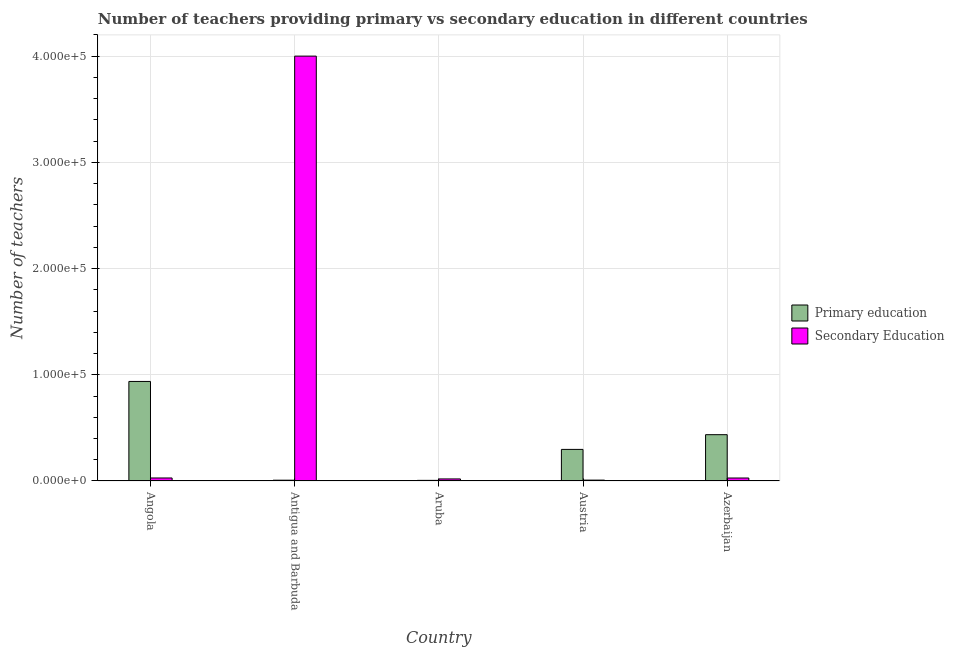How many groups of bars are there?
Offer a very short reply. 5. In how many cases, is the number of bars for a given country not equal to the number of legend labels?
Your answer should be compact. 0. What is the number of primary teachers in Angola?
Keep it short and to the point. 9.37e+04. Across all countries, what is the maximum number of primary teachers?
Provide a succinct answer. 9.37e+04. Across all countries, what is the minimum number of primary teachers?
Provide a short and direct response. 586. In which country was the number of secondary teachers maximum?
Your response must be concise. Antigua and Barbuda. What is the total number of secondary teachers in the graph?
Make the answer very short. 4.08e+05. What is the difference between the number of primary teachers in Angola and that in Aruba?
Offer a terse response. 9.31e+04. What is the difference between the number of primary teachers in Angola and the number of secondary teachers in Aruba?
Offer a very short reply. 9.18e+04. What is the average number of primary teachers per country?
Make the answer very short. 3.37e+04. What is the difference between the number of secondary teachers and number of primary teachers in Azerbaijan?
Your response must be concise. -4.08e+04. In how many countries, is the number of primary teachers greater than 140000 ?
Make the answer very short. 0. What is the ratio of the number of primary teachers in Antigua and Barbuda to that in Austria?
Provide a short and direct response. 0.03. What is the difference between the highest and the second highest number of secondary teachers?
Provide a short and direct response. 3.97e+05. What is the difference between the highest and the lowest number of secondary teachers?
Offer a terse response. 3.99e+05. In how many countries, is the number of primary teachers greater than the average number of primary teachers taken over all countries?
Offer a very short reply. 2. What does the 2nd bar from the left in Aruba represents?
Your response must be concise. Secondary Education. What does the 1st bar from the right in Austria represents?
Ensure brevity in your answer.  Secondary Education. Are all the bars in the graph horizontal?
Your answer should be very brief. No. How many countries are there in the graph?
Your answer should be compact. 5. What is the difference between two consecutive major ticks on the Y-axis?
Offer a very short reply. 1.00e+05. Are the values on the major ticks of Y-axis written in scientific E-notation?
Make the answer very short. Yes. Does the graph contain grids?
Make the answer very short. Yes. How many legend labels are there?
Make the answer very short. 2. What is the title of the graph?
Give a very brief answer. Number of teachers providing primary vs secondary education in different countries. Does "Secondary school" appear as one of the legend labels in the graph?
Provide a short and direct response. No. What is the label or title of the X-axis?
Your response must be concise. Country. What is the label or title of the Y-axis?
Your response must be concise. Number of teachers. What is the Number of teachers of Primary education in Angola?
Offer a very short reply. 9.37e+04. What is the Number of teachers in Secondary Education in Angola?
Keep it short and to the point. 2837. What is the Number of teachers in Primary education in Antigua and Barbuda?
Ensure brevity in your answer.  747. What is the Number of teachers of Secondary Education in Antigua and Barbuda?
Give a very brief answer. 4.00e+05. What is the Number of teachers of Primary education in Aruba?
Provide a short and direct response. 586. What is the Number of teachers of Secondary Education in Aruba?
Offer a very short reply. 1947. What is the Number of teachers in Primary education in Austria?
Your answer should be very brief. 2.97e+04. What is the Number of teachers in Secondary Education in Austria?
Keep it short and to the point. 825. What is the Number of teachers in Primary education in Azerbaijan?
Make the answer very short. 4.36e+04. What is the Number of teachers in Secondary Education in Azerbaijan?
Your response must be concise. 2805. Across all countries, what is the maximum Number of teachers in Primary education?
Your answer should be very brief. 9.37e+04. Across all countries, what is the maximum Number of teachers of Secondary Education?
Provide a short and direct response. 4.00e+05. Across all countries, what is the minimum Number of teachers of Primary education?
Keep it short and to the point. 586. Across all countries, what is the minimum Number of teachers in Secondary Education?
Make the answer very short. 825. What is the total Number of teachers in Primary education in the graph?
Make the answer very short. 1.68e+05. What is the total Number of teachers in Secondary Education in the graph?
Ensure brevity in your answer.  4.08e+05. What is the difference between the Number of teachers of Primary education in Angola and that in Antigua and Barbuda?
Provide a short and direct response. 9.30e+04. What is the difference between the Number of teachers in Secondary Education in Angola and that in Antigua and Barbuda?
Give a very brief answer. -3.97e+05. What is the difference between the Number of teachers in Primary education in Angola and that in Aruba?
Ensure brevity in your answer.  9.31e+04. What is the difference between the Number of teachers of Secondary Education in Angola and that in Aruba?
Offer a very short reply. 890. What is the difference between the Number of teachers in Primary education in Angola and that in Austria?
Provide a short and direct response. 6.40e+04. What is the difference between the Number of teachers in Secondary Education in Angola and that in Austria?
Provide a succinct answer. 2012. What is the difference between the Number of teachers of Primary education in Angola and that in Azerbaijan?
Your answer should be compact. 5.01e+04. What is the difference between the Number of teachers of Secondary Education in Angola and that in Azerbaijan?
Give a very brief answer. 32. What is the difference between the Number of teachers of Primary education in Antigua and Barbuda and that in Aruba?
Your answer should be compact. 161. What is the difference between the Number of teachers of Secondary Education in Antigua and Barbuda and that in Aruba?
Provide a succinct answer. 3.98e+05. What is the difference between the Number of teachers in Primary education in Antigua and Barbuda and that in Austria?
Make the answer very short. -2.90e+04. What is the difference between the Number of teachers in Secondary Education in Antigua and Barbuda and that in Austria?
Your answer should be very brief. 3.99e+05. What is the difference between the Number of teachers in Primary education in Antigua and Barbuda and that in Azerbaijan?
Your answer should be compact. -4.29e+04. What is the difference between the Number of teachers of Secondary Education in Antigua and Barbuda and that in Azerbaijan?
Make the answer very short. 3.97e+05. What is the difference between the Number of teachers in Primary education in Aruba and that in Austria?
Offer a very short reply. -2.92e+04. What is the difference between the Number of teachers in Secondary Education in Aruba and that in Austria?
Make the answer very short. 1122. What is the difference between the Number of teachers of Primary education in Aruba and that in Azerbaijan?
Keep it short and to the point. -4.30e+04. What is the difference between the Number of teachers of Secondary Education in Aruba and that in Azerbaijan?
Ensure brevity in your answer.  -858. What is the difference between the Number of teachers of Primary education in Austria and that in Azerbaijan?
Provide a succinct answer. -1.39e+04. What is the difference between the Number of teachers of Secondary Education in Austria and that in Azerbaijan?
Give a very brief answer. -1980. What is the difference between the Number of teachers in Primary education in Angola and the Number of teachers in Secondary Education in Antigua and Barbuda?
Ensure brevity in your answer.  -3.06e+05. What is the difference between the Number of teachers in Primary education in Angola and the Number of teachers in Secondary Education in Aruba?
Make the answer very short. 9.18e+04. What is the difference between the Number of teachers in Primary education in Angola and the Number of teachers in Secondary Education in Austria?
Your response must be concise. 9.29e+04. What is the difference between the Number of teachers in Primary education in Angola and the Number of teachers in Secondary Education in Azerbaijan?
Your response must be concise. 9.09e+04. What is the difference between the Number of teachers of Primary education in Antigua and Barbuda and the Number of teachers of Secondary Education in Aruba?
Ensure brevity in your answer.  -1200. What is the difference between the Number of teachers of Primary education in Antigua and Barbuda and the Number of teachers of Secondary Education in Austria?
Ensure brevity in your answer.  -78. What is the difference between the Number of teachers of Primary education in Antigua and Barbuda and the Number of teachers of Secondary Education in Azerbaijan?
Offer a very short reply. -2058. What is the difference between the Number of teachers in Primary education in Aruba and the Number of teachers in Secondary Education in Austria?
Make the answer very short. -239. What is the difference between the Number of teachers in Primary education in Aruba and the Number of teachers in Secondary Education in Azerbaijan?
Give a very brief answer. -2219. What is the difference between the Number of teachers in Primary education in Austria and the Number of teachers in Secondary Education in Azerbaijan?
Provide a short and direct response. 2.69e+04. What is the average Number of teachers of Primary education per country?
Keep it short and to the point. 3.37e+04. What is the average Number of teachers in Secondary Education per country?
Ensure brevity in your answer.  8.17e+04. What is the difference between the Number of teachers in Primary education and Number of teachers in Secondary Education in Angola?
Your answer should be very brief. 9.09e+04. What is the difference between the Number of teachers of Primary education and Number of teachers of Secondary Education in Antigua and Barbuda?
Your answer should be compact. -3.99e+05. What is the difference between the Number of teachers in Primary education and Number of teachers in Secondary Education in Aruba?
Provide a succinct answer. -1361. What is the difference between the Number of teachers of Primary education and Number of teachers of Secondary Education in Austria?
Make the answer very short. 2.89e+04. What is the difference between the Number of teachers of Primary education and Number of teachers of Secondary Education in Azerbaijan?
Offer a very short reply. 4.08e+04. What is the ratio of the Number of teachers of Primary education in Angola to that in Antigua and Barbuda?
Make the answer very short. 125.48. What is the ratio of the Number of teachers of Secondary Education in Angola to that in Antigua and Barbuda?
Offer a very short reply. 0.01. What is the ratio of the Number of teachers in Primary education in Angola to that in Aruba?
Your answer should be very brief. 159.96. What is the ratio of the Number of teachers of Secondary Education in Angola to that in Aruba?
Your answer should be compact. 1.46. What is the ratio of the Number of teachers of Primary education in Angola to that in Austria?
Provide a succinct answer. 3.15. What is the ratio of the Number of teachers of Secondary Education in Angola to that in Austria?
Ensure brevity in your answer.  3.44. What is the ratio of the Number of teachers in Primary education in Angola to that in Azerbaijan?
Make the answer very short. 2.15. What is the ratio of the Number of teachers in Secondary Education in Angola to that in Azerbaijan?
Your answer should be very brief. 1.01. What is the ratio of the Number of teachers in Primary education in Antigua and Barbuda to that in Aruba?
Keep it short and to the point. 1.27. What is the ratio of the Number of teachers in Secondary Education in Antigua and Barbuda to that in Aruba?
Ensure brevity in your answer.  205.47. What is the ratio of the Number of teachers in Primary education in Antigua and Barbuda to that in Austria?
Provide a succinct answer. 0.03. What is the ratio of the Number of teachers of Secondary Education in Antigua and Barbuda to that in Austria?
Your answer should be very brief. 484.91. What is the ratio of the Number of teachers in Primary education in Antigua and Barbuda to that in Azerbaijan?
Make the answer very short. 0.02. What is the ratio of the Number of teachers of Secondary Education in Antigua and Barbuda to that in Azerbaijan?
Make the answer very short. 142.62. What is the ratio of the Number of teachers in Primary education in Aruba to that in Austria?
Offer a terse response. 0.02. What is the ratio of the Number of teachers in Secondary Education in Aruba to that in Austria?
Provide a succinct answer. 2.36. What is the ratio of the Number of teachers of Primary education in Aruba to that in Azerbaijan?
Make the answer very short. 0.01. What is the ratio of the Number of teachers of Secondary Education in Aruba to that in Azerbaijan?
Your answer should be compact. 0.69. What is the ratio of the Number of teachers in Primary education in Austria to that in Azerbaijan?
Offer a terse response. 0.68. What is the ratio of the Number of teachers of Secondary Education in Austria to that in Azerbaijan?
Provide a succinct answer. 0.29. What is the difference between the highest and the second highest Number of teachers of Primary education?
Ensure brevity in your answer.  5.01e+04. What is the difference between the highest and the second highest Number of teachers in Secondary Education?
Keep it short and to the point. 3.97e+05. What is the difference between the highest and the lowest Number of teachers in Primary education?
Your answer should be very brief. 9.31e+04. What is the difference between the highest and the lowest Number of teachers of Secondary Education?
Provide a succinct answer. 3.99e+05. 